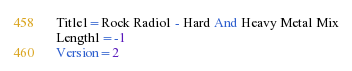Convert code to text. <code><loc_0><loc_0><loc_500><loc_500><_SQL_>Title1=Rock Radio1 - Hard And Heavy Metal Mix
Length1=-1
Version=2
</code> 